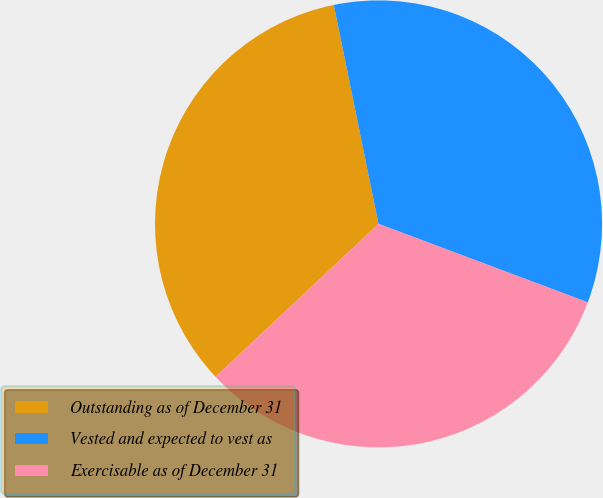<chart> <loc_0><loc_0><loc_500><loc_500><pie_chart><fcel>Outstanding as of December 31<fcel>Vested and expected to vest as<fcel>Exercisable as of December 31<nl><fcel>33.78%<fcel>33.92%<fcel>32.3%<nl></chart> 